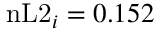<formula> <loc_0><loc_0><loc_500><loc_500>n L 2 _ { i } = 0 . 1 5 2</formula> 